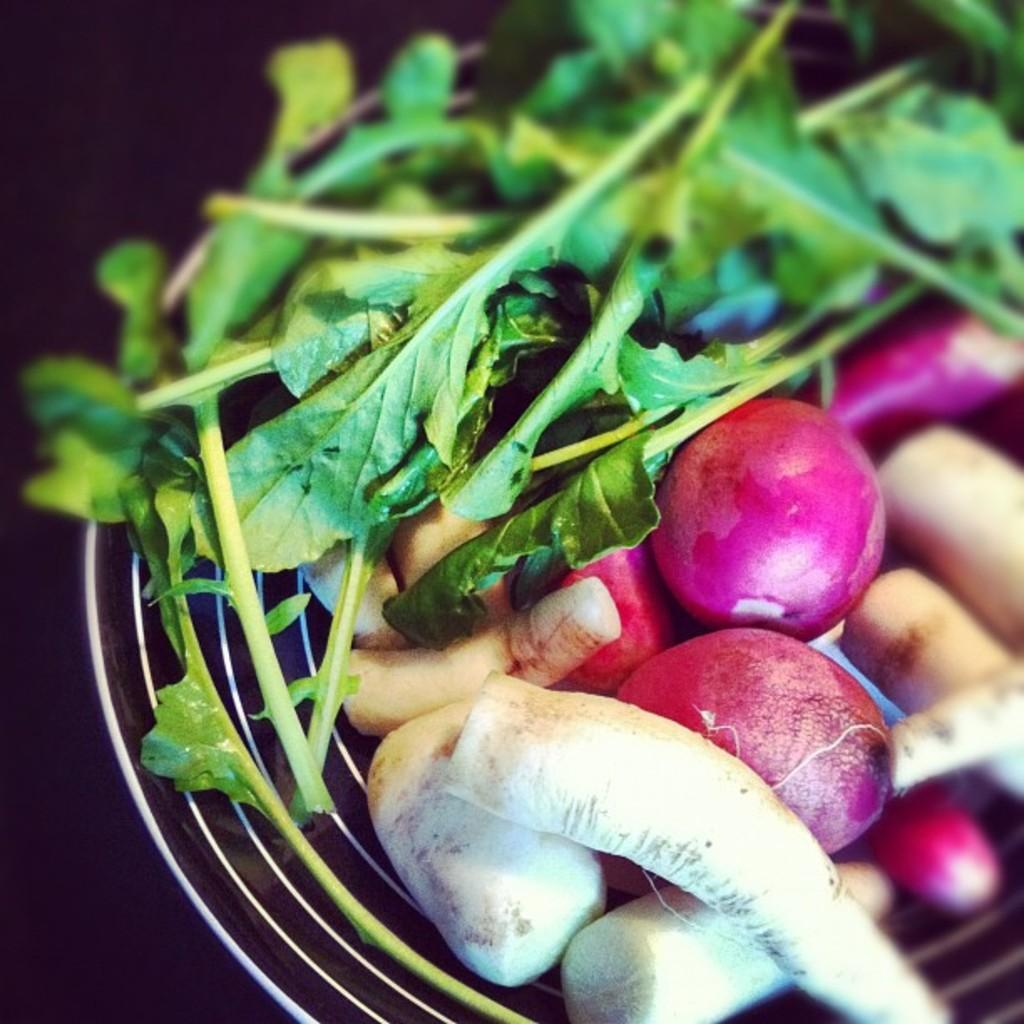What object is present in the image that can hold items? There is a basket in the image that can hold items. What type of items are in the basket? The basket contains leafy vegetables and other vegetables. What can be inferred about the background of the image? The background of the image is black. What type of treatment is being administered to the vegetables in the image? There is no treatment being administered to the vegetables in the image; they are simply contained in a basket. 